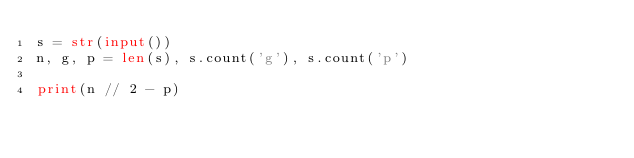<code> <loc_0><loc_0><loc_500><loc_500><_Python_>s = str(input())
n, g, p = len(s), s.count('g'), s.count('p')

print(n // 2 - p)
</code> 